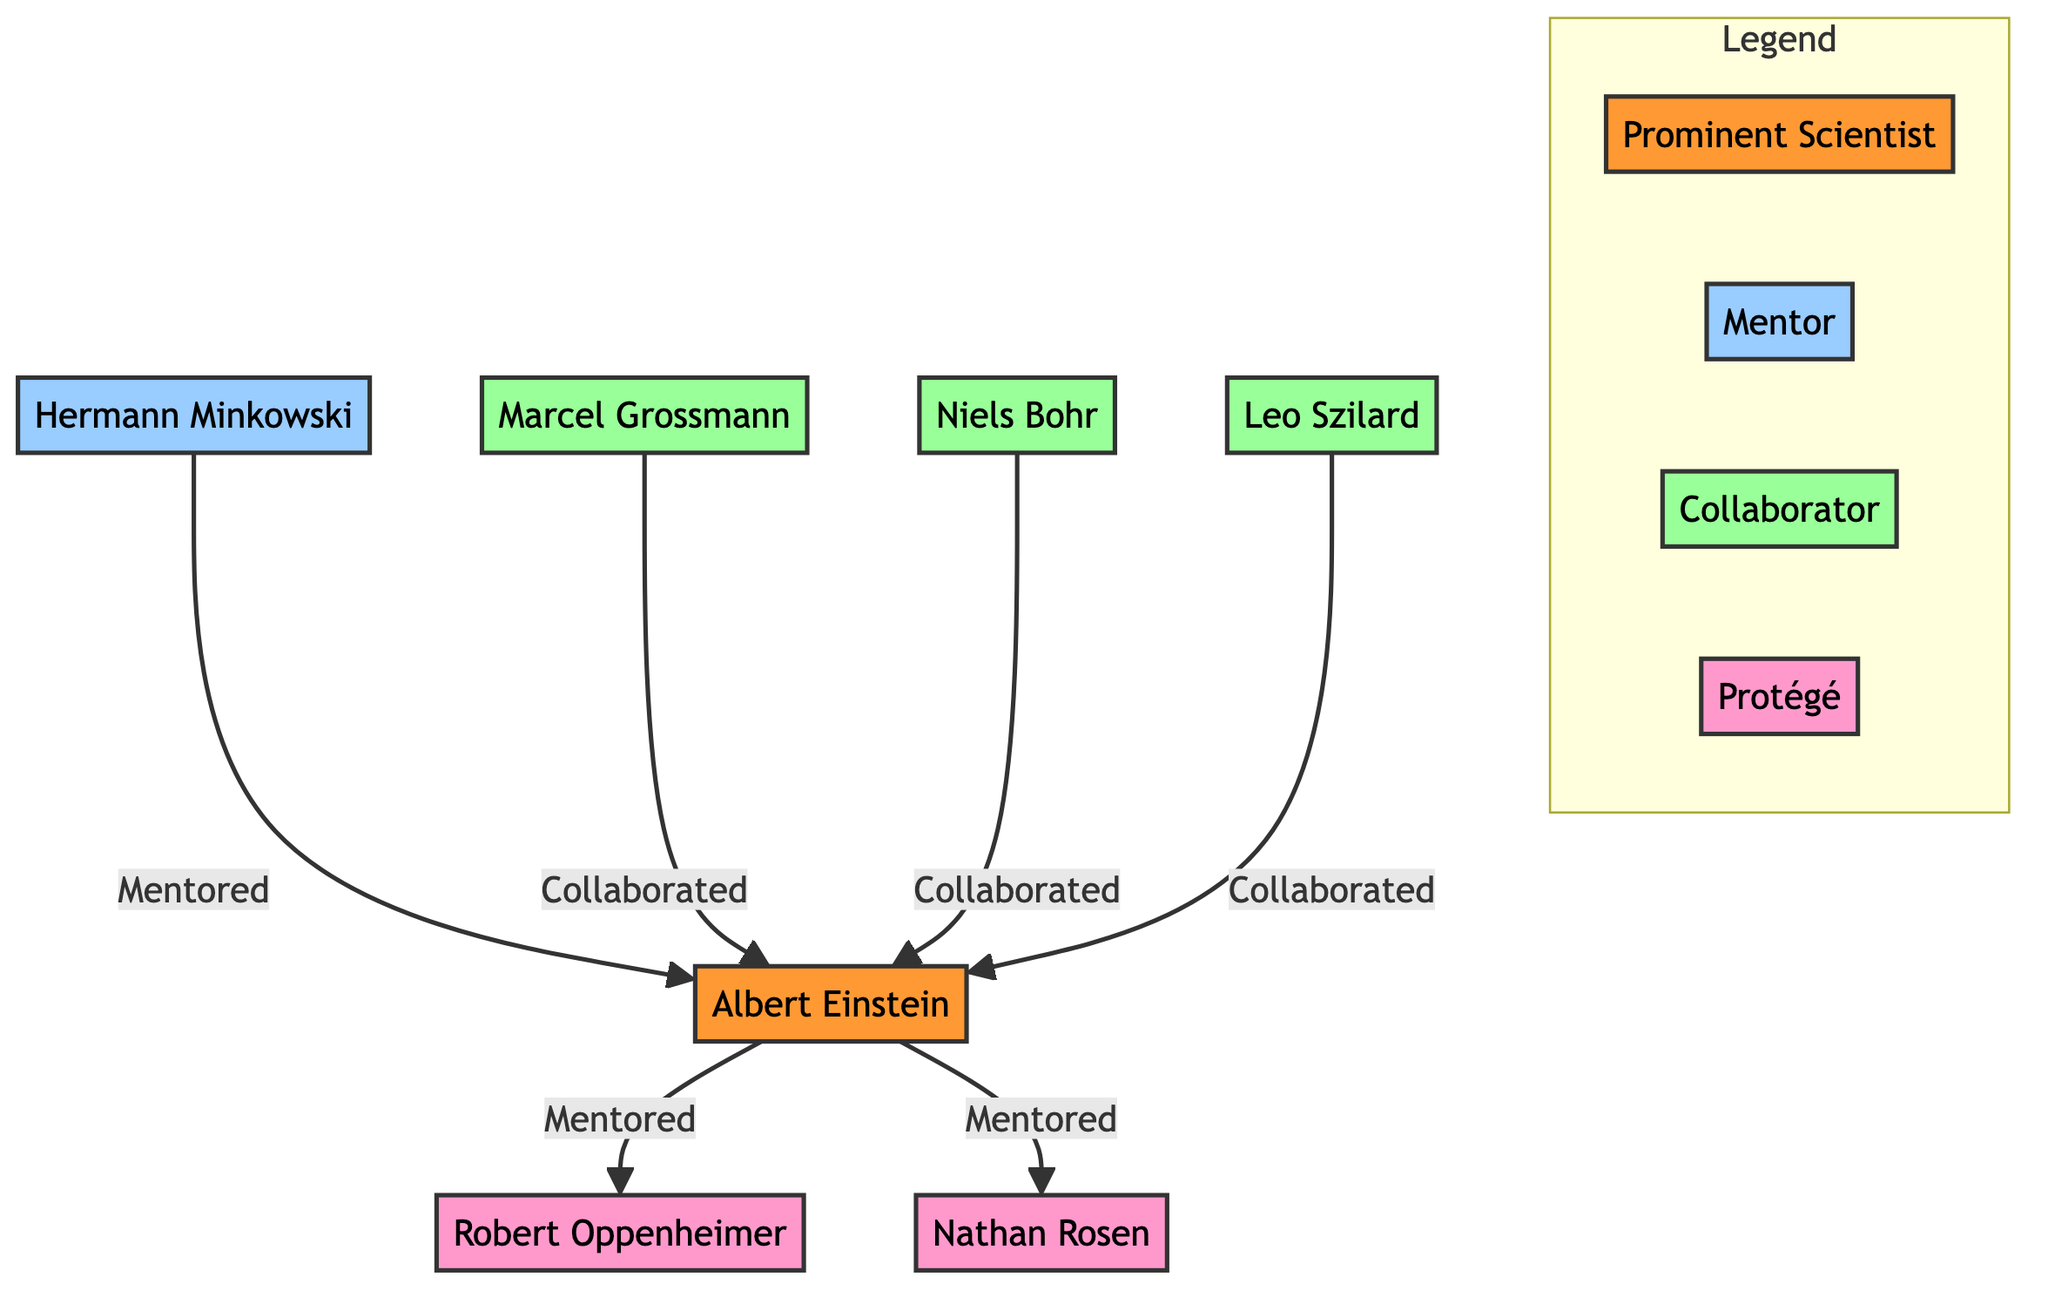What is the name of the prominent scientist in the diagram? The diagram identifies "Albert Einstein" as the prominent scientist at the top of the flowchart.
Answer: Albert Einstein How many collaborators are shown in the diagram? By counting the nodes connected to Albert Einstein with the label "Collaborated," we find there are three collaborators: Marcel Grossmann, Niels Bohr, and Leo Szilard.
Answer: 3 Who mentored Albert Einstein? The diagram shows that "Hermann Minkowski" is the individual connected to Albert Einstein with the label "Mentored".
Answer: Hermann Minkowski Which protégé is mentioned in the diagram? The diagram indicates "Robert Oppenheimer" and "Nathan Rosen" as protégés of Albert Einstein since they are labeled with "Mentored".
Answer: Robert Oppenheimer, Nathan Rosen What type of relationship does Marcel Grossmann have with Albert Einstein? The relationship is defined by the direction of the arrow from Marcel Grossmann to Albert Einstein with the label "Collaborated". This indicates a collaborative relationship.
Answer: Collaborated How many total nodes (scientists, mentors, collaborators, and protégés) are present in the diagram? By counting, there are a total of six nodes: 1 prominent scientist (Albert Einstein), 1 mentor (Hermann Minkowski), 3 collaborators (Marcel Grossmann, Niels Bohr, Leo Szilard), and 2 protégés (Robert Oppenheimer, Nathan Rosen), leading to 7 nodes in total.
Answer: 7 What is the total number of edges in the diagram? Each relationship represented by a direction-filled arrow is an edge. The edges are: Minkowski to Einstein, Grossmann to Einstein, Bohr to Einstein, Szilard to Einstein, Einstein to Oppenheimer, and Einstein to Rosen, making a total of 6 edges.
Answer: 6 What color represents a mentor in the diagram? Looking at the legend, the color assigned to mentors is light blue (#99CCFF).
Answer: Light Blue Which connections indicate mentorship in the diagram? The arrows leading from Hermann Minkowski to Albert Einstein and from Albert Einstein to both Robert Oppenheimer and Nathan Rosen represent mentorship.
Answer: Hermann Minkowski to Albert Einstein, Albert Einstein to Robert Oppenheimer, Albert Einstein to Nathan Rosen 